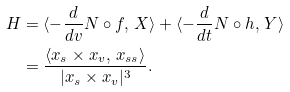<formula> <loc_0><loc_0><loc_500><loc_500>H & = \langle - \frac { d } { d v } N \circ f , \, X \rangle + \langle - \frac { d } { d t } N \circ h , \, Y \rangle \\ & = \frac { \langle x _ { s } \times x _ { v } , \, x _ { s s } \rangle } { | x _ { s } \times x _ { v } | ^ { 3 } } .</formula> 